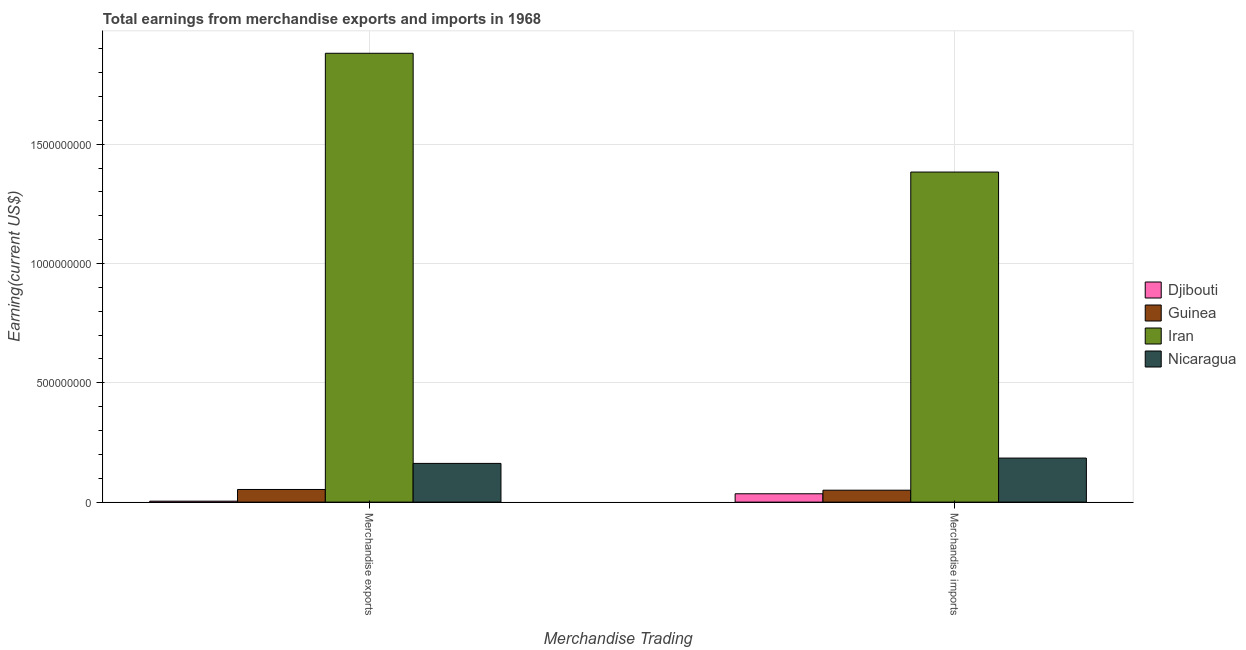How many bars are there on the 2nd tick from the left?
Keep it short and to the point. 4. How many bars are there on the 1st tick from the right?
Your answer should be compact. 4. What is the label of the 1st group of bars from the left?
Give a very brief answer. Merchandise exports. What is the earnings from merchandise exports in Nicaragua?
Offer a terse response. 1.62e+08. Across all countries, what is the maximum earnings from merchandise imports?
Ensure brevity in your answer.  1.38e+09. Across all countries, what is the minimum earnings from merchandise exports?
Offer a very short reply. 4.00e+06. In which country was the earnings from merchandise exports maximum?
Provide a short and direct response. Iran. In which country was the earnings from merchandise imports minimum?
Make the answer very short. Djibouti. What is the total earnings from merchandise exports in the graph?
Your response must be concise. 2.10e+09. What is the difference between the earnings from merchandise exports in Iran and that in Djibouti?
Offer a terse response. 1.88e+09. What is the difference between the earnings from merchandise imports in Iran and the earnings from merchandise exports in Nicaragua?
Your answer should be very brief. 1.22e+09. What is the average earnings from merchandise imports per country?
Your response must be concise. 4.13e+08. What is the difference between the earnings from merchandise imports and earnings from merchandise exports in Djibouti?
Your answer should be very brief. 3.10e+07. In how many countries, is the earnings from merchandise exports greater than 1700000000 US$?
Provide a short and direct response. 1. What is the ratio of the earnings from merchandise exports in Nicaragua to that in Iran?
Make the answer very short. 0.09. Is the earnings from merchandise exports in Iran less than that in Guinea?
Offer a very short reply. No. What does the 4th bar from the left in Merchandise imports represents?
Provide a short and direct response. Nicaragua. What does the 2nd bar from the right in Merchandise exports represents?
Make the answer very short. Iran. How many bars are there?
Your response must be concise. 8. How many legend labels are there?
Give a very brief answer. 4. What is the title of the graph?
Offer a very short reply. Total earnings from merchandise exports and imports in 1968. What is the label or title of the X-axis?
Provide a short and direct response. Merchandise Trading. What is the label or title of the Y-axis?
Make the answer very short. Earning(current US$). What is the Earning(current US$) in Guinea in Merchandise exports?
Your answer should be very brief. 5.30e+07. What is the Earning(current US$) of Iran in Merchandise exports?
Ensure brevity in your answer.  1.88e+09. What is the Earning(current US$) of Nicaragua in Merchandise exports?
Provide a short and direct response. 1.62e+08. What is the Earning(current US$) of Djibouti in Merchandise imports?
Make the answer very short. 3.50e+07. What is the Earning(current US$) in Guinea in Merchandise imports?
Keep it short and to the point. 5.00e+07. What is the Earning(current US$) of Iran in Merchandise imports?
Your answer should be compact. 1.38e+09. What is the Earning(current US$) in Nicaragua in Merchandise imports?
Offer a very short reply. 1.85e+08. Across all Merchandise Trading, what is the maximum Earning(current US$) of Djibouti?
Provide a short and direct response. 3.50e+07. Across all Merchandise Trading, what is the maximum Earning(current US$) in Guinea?
Provide a short and direct response. 5.30e+07. Across all Merchandise Trading, what is the maximum Earning(current US$) in Iran?
Provide a succinct answer. 1.88e+09. Across all Merchandise Trading, what is the maximum Earning(current US$) in Nicaragua?
Your answer should be very brief. 1.85e+08. Across all Merchandise Trading, what is the minimum Earning(current US$) in Iran?
Provide a succinct answer. 1.38e+09. Across all Merchandise Trading, what is the minimum Earning(current US$) of Nicaragua?
Your response must be concise. 1.62e+08. What is the total Earning(current US$) in Djibouti in the graph?
Offer a very short reply. 3.90e+07. What is the total Earning(current US$) of Guinea in the graph?
Make the answer very short. 1.03e+08. What is the total Earning(current US$) of Iran in the graph?
Offer a terse response. 3.26e+09. What is the total Earning(current US$) of Nicaragua in the graph?
Make the answer very short. 3.47e+08. What is the difference between the Earning(current US$) in Djibouti in Merchandise exports and that in Merchandise imports?
Provide a short and direct response. -3.10e+07. What is the difference between the Earning(current US$) of Iran in Merchandise exports and that in Merchandise imports?
Your answer should be very brief. 4.98e+08. What is the difference between the Earning(current US$) of Nicaragua in Merchandise exports and that in Merchandise imports?
Offer a very short reply. -2.24e+07. What is the difference between the Earning(current US$) of Djibouti in Merchandise exports and the Earning(current US$) of Guinea in Merchandise imports?
Offer a terse response. -4.60e+07. What is the difference between the Earning(current US$) of Djibouti in Merchandise exports and the Earning(current US$) of Iran in Merchandise imports?
Provide a succinct answer. -1.38e+09. What is the difference between the Earning(current US$) of Djibouti in Merchandise exports and the Earning(current US$) of Nicaragua in Merchandise imports?
Provide a short and direct response. -1.81e+08. What is the difference between the Earning(current US$) in Guinea in Merchandise exports and the Earning(current US$) in Iran in Merchandise imports?
Offer a very short reply. -1.33e+09. What is the difference between the Earning(current US$) in Guinea in Merchandise exports and the Earning(current US$) in Nicaragua in Merchandise imports?
Keep it short and to the point. -1.32e+08. What is the difference between the Earning(current US$) in Iran in Merchandise exports and the Earning(current US$) in Nicaragua in Merchandise imports?
Offer a very short reply. 1.70e+09. What is the average Earning(current US$) in Djibouti per Merchandise Trading?
Provide a succinct answer. 1.95e+07. What is the average Earning(current US$) in Guinea per Merchandise Trading?
Your answer should be compact. 5.15e+07. What is the average Earning(current US$) in Iran per Merchandise Trading?
Your answer should be compact. 1.63e+09. What is the average Earning(current US$) of Nicaragua per Merchandise Trading?
Your answer should be compact. 1.73e+08. What is the difference between the Earning(current US$) of Djibouti and Earning(current US$) of Guinea in Merchandise exports?
Offer a terse response. -4.90e+07. What is the difference between the Earning(current US$) in Djibouti and Earning(current US$) in Iran in Merchandise exports?
Make the answer very short. -1.88e+09. What is the difference between the Earning(current US$) of Djibouti and Earning(current US$) of Nicaragua in Merchandise exports?
Your response must be concise. -1.58e+08. What is the difference between the Earning(current US$) in Guinea and Earning(current US$) in Iran in Merchandise exports?
Keep it short and to the point. -1.83e+09. What is the difference between the Earning(current US$) in Guinea and Earning(current US$) in Nicaragua in Merchandise exports?
Offer a very short reply. -1.09e+08. What is the difference between the Earning(current US$) in Iran and Earning(current US$) in Nicaragua in Merchandise exports?
Ensure brevity in your answer.  1.72e+09. What is the difference between the Earning(current US$) of Djibouti and Earning(current US$) of Guinea in Merchandise imports?
Keep it short and to the point. -1.50e+07. What is the difference between the Earning(current US$) in Djibouti and Earning(current US$) in Iran in Merchandise imports?
Your response must be concise. -1.35e+09. What is the difference between the Earning(current US$) in Djibouti and Earning(current US$) in Nicaragua in Merchandise imports?
Your answer should be compact. -1.50e+08. What is the difference between the Earning(current US$) of Guinea and Earning(current US$) of Iran in Merchandise imports?
Your response must be concise. -1.33e+09. What is the difference between the Earning(current US$) of Guinea and Earning(current US$) of Nicaragua in Merchandise imports?
Your answer should be compact. -1.35e+08. What is the difference between the Earning(current US$) of Iran and Earning(current US$) of Nicaragua in Merchandise imports?
Provide a succinct answer. 1.20e+09. What is the ratio of the Earning(current US$) of Djibouti in Merchandise exports to that in Merchandise imports?
Make the answer very short. 0.11. What is the ratio of the Earning(current US$) in Guinea in Merchandise exports to that in Merchandise imports?
Provide a short and direct response. 1.06. What is the ratio of the Earning(current US$) in Iran in Merchandise exports to that in Merchandise imports?
Offer a terse response. 1.36. What is the ratio of the Earning(current US$) of Nicaragua in Merchandise exports to that in Merchandise imports?
Give a very brief answer. 0.88. What is the difference between the highest and the second highest Earning(current US$) in Djibouti?
Your response must be concise. 3.10e+07. What is the difference between the highest and the second highest Earning(current US$) in Iran?
Ensure brevity in your answer.  4.98e+08. What is the difference between the highest and the second highest Earning(current US$) of Nicaragua?
Offer a very short reply. 2.24e+07. What is the difference between the highest and the lowest Earning(current US$) of Djibouti?
Provide a short and direct response. 3.10e+07. What is the difference between the highest and the lowest Earning(current US$) of Guinea?
Make the answer very short. 3.00e+06. What is the difference between the highest and the lowest Earning(current US$) of Iran?
Your response must be concise. 4.98e+08. What is the difference between the highest and the lowest Earning(current US$) of Nicaragua?
Offer a very short reply. 2.24e+07. 